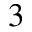<formula> <loc_0><loc_0><loc_500><loc_500>3</formula> 